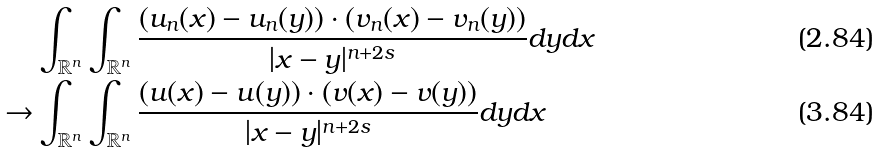Convert formula to latex. <formula><loc_0><loc_0><loc_500><loc_500>& \int _ { \mathbb { R } ^ { n } } \int _ { \mathbb { R } ^ { n } } \frac { ( u _ { n } ( x ) - u _ { n } ( y ) ) \cdot ( v _ { n } ( x ) - v _ { n } ( y ) ) } { | x - y | ^ { n + 2 s } } d y d x \\ \to & \int _ { \mathbb { R } ^ { n } } \int _ { \mathbb { R } ^ { n } } \frac { ( u ( x ) - u ( y ) ) \cdot ( v ( x ) - v ( y ) ) } { | x - y | ^ { n + 2 s } } d y d x</formula> 